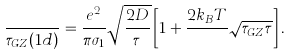<formula> <loc_0><loc_0><loc_500><loc_500>\frac { } { \tau _ { G Z } ( 1 d ) } = \frac { e ^ { 2 } } { \pi \sigma _ { 1 } } \sqrt { \frac { 2 D } { \tau } } \left [ 1 + \frac { 2 k _ { B } T } { } \sqrt { \tau _ { G Z } \tau } \right ] .</formula> 